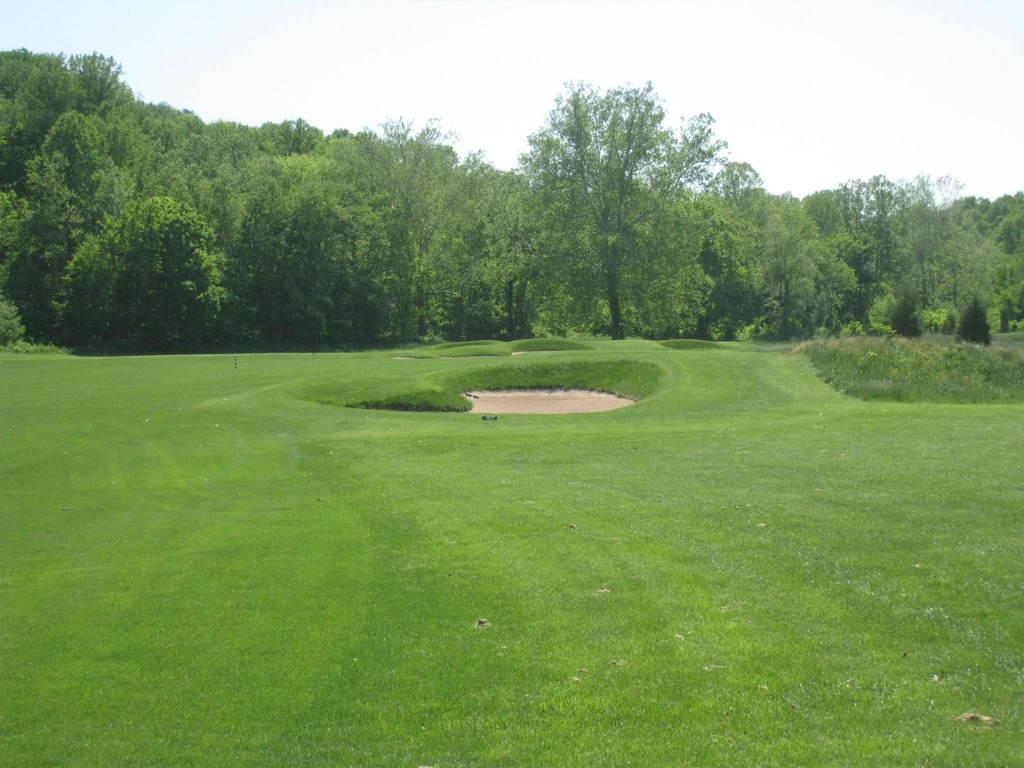What can be seen at the top of the image? The sky is visible towards the top of the image. What type of vegetation is present in the image? There are trees and plants in the image. Where is the grass located in the image? There is grass towards the bottom of the image. Where is the library located in the image? There is no library present in the image. What type of notebook is visible in the image? There is no notebook present in the image. 